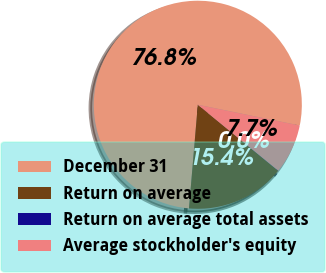Convert chart. <chart><loc_0><loc_0><loc_500><loc_500><pie_chart><fcel>December 31<fcel>Return on average<fcel>Return on average total assets<fcel>Average stockholder's equity<nl><fcel>76.85%<fcel>15.4%<fcel>0.03%<fcel>7.72%<nl></chart> 